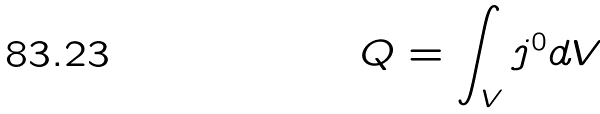Convert formula to latex. <formula><loc_0><loc_0><loc_500><loc_500>Q = \int _ { V } j ^ { 0 } d V</formula> 